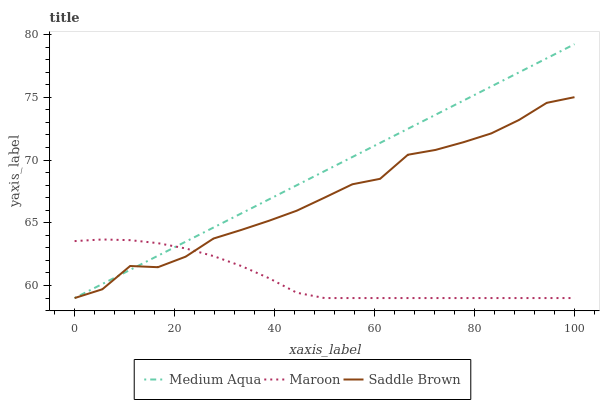Does Maroon have the minimum area under the curve?
Answer yes or no. Yes. Does Medium Aqua have the maximum area under the curve?
Answer yes or no. Yes. Does Saddle Brown have the minimum area under the curve?
Answer yes or no. No. Does Saddle Brown have the maximum area under the curve?
Answer yes or no. No. Is Medium Aqua the smoothest?
Answer yes or no. Yes. Is Saddle Brown the roughest?
Answer yes or no. Yes. Is Maroon the smoothest?
Answer yes or no. No. Is Maroon the roughest?
Answer yes or no. No. Does Medium Aqua have the lowest value?
Answer yes or no. Yes. Does Medium Aqua have the highest value?
Answer yes or no. Yes. Does Saddle Brown have the highest value?
Answer yes or no. No. Does Medium Aqua intersect Saddle Brown?
Answer yes or no. Yes. Is Medium Aqua less than Saddle Brown?
Answer yes or no. No. Is Medium Aqua greater than Saddle Brown?
Answer yes or no. No. 